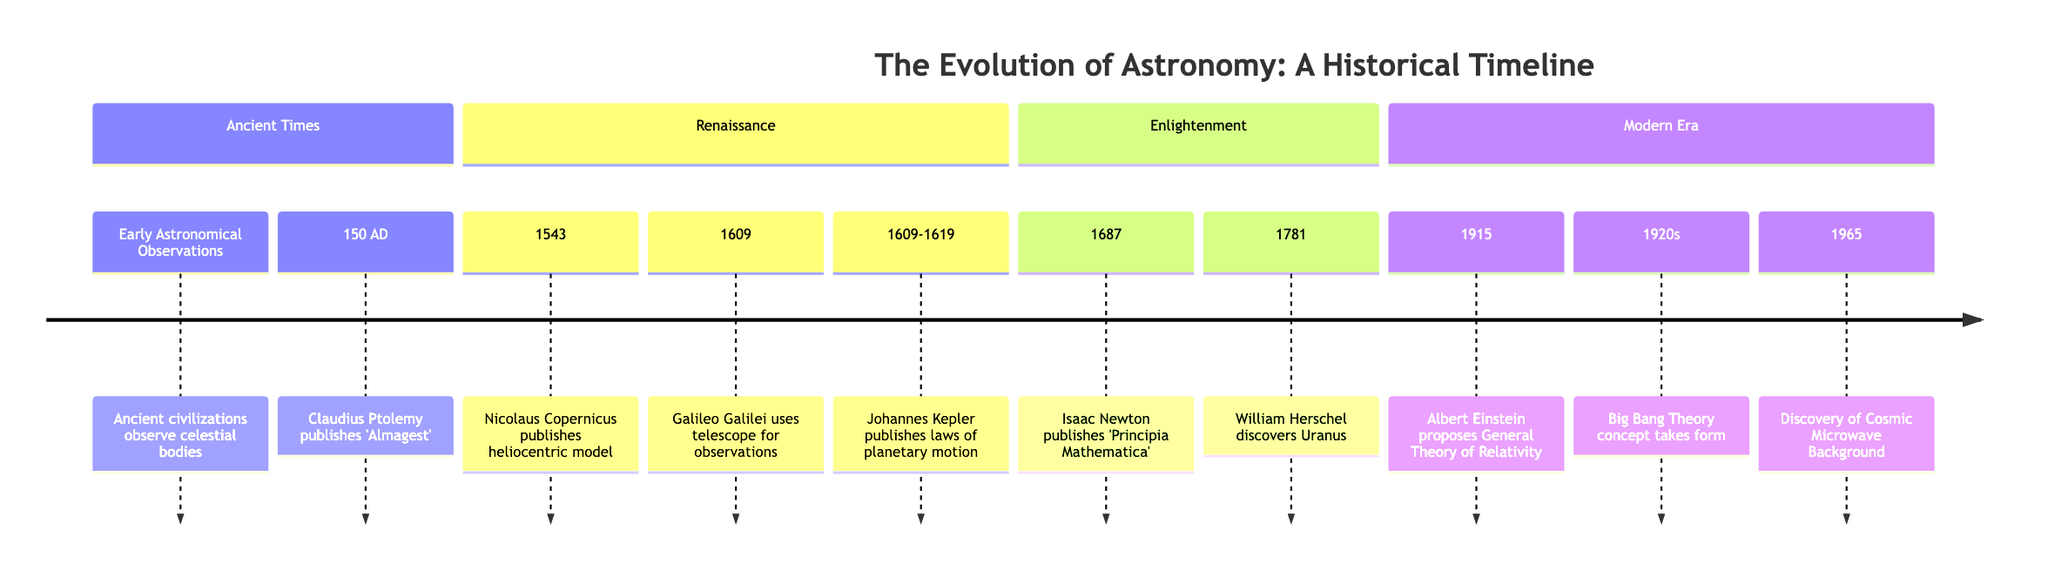What publication did Claudius Ptolemy release in 150 AD? The diagram indicates that Claudius Ptolemy published the 'Almagest' in 150 AD, which is the significant node related to early astronomy.
Answer: Almagest Who discovered Uranus? According to the diagram, the year 1781 is marked with the discovery of Uranus by William Herschel, connecting the discovery directly to him.
Answer: William Herschel What theory did Albert Einstein propose in 1915? The diagram shows that Albert Einstein proposed the General Theory of Relativity in 1915, signifying a major advancement in modern astronomy.
Answer: General Theory of Relativity How many major discoveries/from the Ancient times section? The Ancient Times section contains two major discoveries: early astronomical observations and the publication of 'Almagest' by Ptolemy, thus the total is two.
Answer: 2 Which astronomer used a telescope for observations? The timeline indicates that Galileo Galilei, in the year 1609, was the one who used a telescope for observing celestial bodies, marking an essential development in the field.
Answer: Galileo Galilei Which model did Nicolaus Copernicus publish in 1543? The diagram specifies that Nicolaus Copernicus published the heliocentric model in 1543, denoting a pivotal shift in the understanding of our solar system.
Answer: Heliocentric model What significant concept emerged in the 1920s? According to the diagram, the concept of the Big Bang Theory began to take form during the 1920s, indicating a crucial idea in modern cosmology.
Answer: Big Bang Theory Which mathematical publication did Isaac Newton release in 1687? The timeline highlights that Isaac Newton published 'Principia Mathematica' in 1687, which is a foundational text in physics and mathematics.
Answer: Principia Mathematica What discovery is marked in 1965? The diagram indicates that 1965 is associated with the discovery of the Cosmic Microwave Background, marking an important milestone in modern astronomy.
Answer: Cosmic Microwave Background 